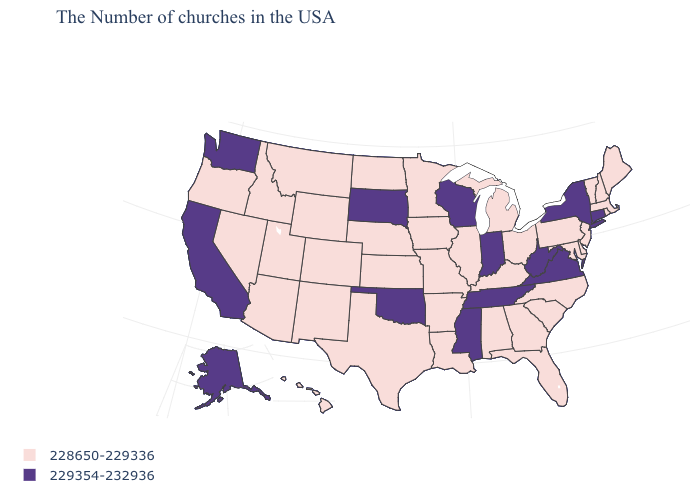Name the states that have a value in the range 229354-232936?
Quick response, please. Connecticut, New York, Virginia, West Virginia, Indiana, Tennessee, Wisconsin, Mississippi, Oklahoma, South Dakota, California, Washington, Alaska. What is the value of Delaware?
Keep it brief. 228650-229336. Does Tennessee have the same value as New York?
Concise answer only. Yes. Which states hav the highest value in the Northeast?
Be succinct. Connecticut, New York. What is the lowest value in the USA?
Quick response, please. 228650-229336. Does Washington have the highest value in the USA?
Be succinct. Yes. Name the states that have a value in the range 228650-229336?
Concise answer only. Maine, Massachusetts, Rhode Island, New Hampshire, Vermont, New Jersey, Delaware, Maryland, Pennsylvania, North Carolina, South Carolina, Ohio, Florida, Georgia, Michigan, Kentucky, Alabama, Illinois, Louisiana, Missouri, Arkansas, Minnesota, Iowa, Kansas, Nebraska, Texas, North Dakota, Wyoming, Colorado, New Mexico, Utah, Montana, Arizona, Idaho, Nevada, Oregon, Hawaii. What is the value of Kansas?
Answer briefly. 228650-229336. What is the value of Arizona?
Be succinct. 228650-229336. Among the states that border Texas , does Oklahoma have the highest value?
Short answer required. Yes. What is the highest value in the Northeast ?
Answer briefly. 229354-232936. What is the lowest value in states that border Nevada?
Keep it brief. 228650-229336. What is the highest value in the USA?
Write a very short answer. 229354-232936. What is the value of Oklahoma?
Give a very brief answer. 229354-232936. 